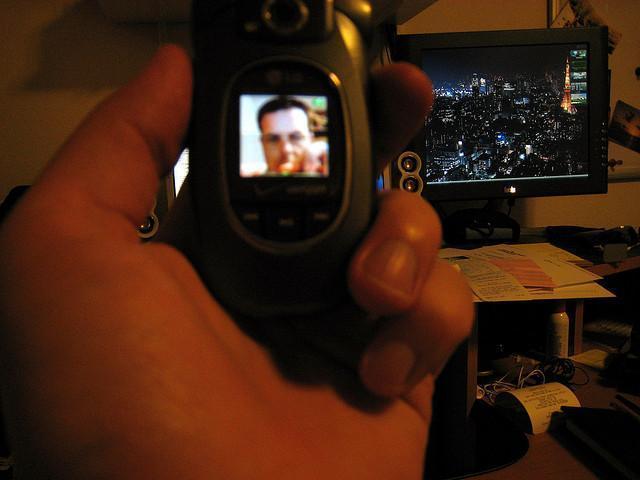What type of telephone does this person have?
Pick the right solution, then justify: 'Answer: answer
Rationale: rationale.'
Options: Cellular, rotary, payphone, landline. Answer: cellular.
Rationale: The phone is a cell phone. 